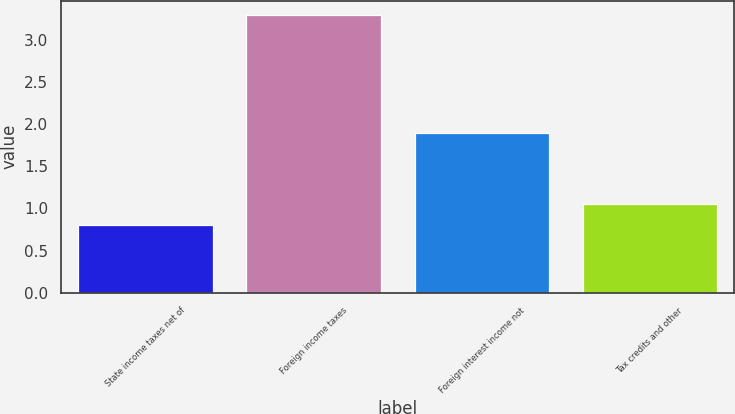<chart> <loc_0><loc_0><loc_500><loc_500><bar_chart><fcel>State income taxes net of<fcel>Foreign income taxes<fcel>Foreign interest income not<fcel>Tax credits and other<nl><fcel>0.8<fcel>3.3<fcel>1.9<fcel>1.05<nl></chart> 